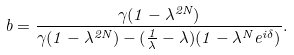Convert formula to latex. <formula><loc_0><loc_0><loc_500><loc_500>b = \frac { \gamma ( 1 - \lambda ^ { 2 N } ) } { \gamma ( 1 - \lambda ^ { 2 N } ) - ( \frac { 1 } { \lambda } - \lambda ) ( 1 - \lambda ^ { N } e ^ { i \delta } ) } .</formula> 